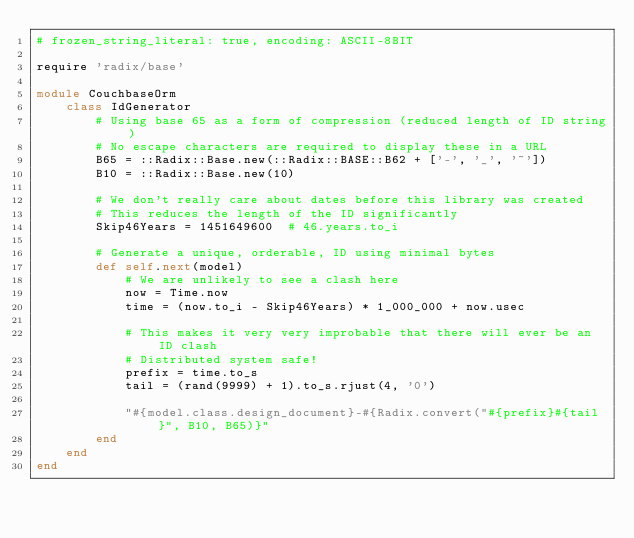Convert code to text. <code><loc_0><loc_0><loc_500><loc_500><_Ruby_># frozen_string_literal: true, encoding: ASCII-8BIT

require 'radix/base'

module CouchbaseOrm
    class IdGenerator
        # Using base 65 as a form of compression (reduced length of ID string)
        # No escape characters are required to display these in a URL
        B65 = ::Radix::Base.new(::Radix::BASE::B62 + ['-', '_', '~'])
        B10 = ::Radix::Base.new(10)

        # We don't really care about dates before this library was created
        # This reduces the length of the ID significantly
        Skip46Years = 1451649600  # 46.years.to_i

        # Generate a unique, orderable, ID using minimal bytes
        def self.next(model)
            # We are unlikely to see a clash here
            now = Time.now
            time = (now.to_i - Skip46Years) * 1_000_000 + now.usec

            # This makes it very very improbable that there will ever be an ID clash
            # Distributed system safe!
            prefix = time.to_s
            tail = (rand(9999) + 1).to_s.rjust(4, '0')

            "#{model.class.design_document}-#{Radix.convert("#{prefix}#{tail}", B10, B65)}"
        end
    end
end
</code> 